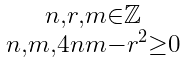Convert formula to latex. <formula><loc_0><loc_0><loc_500><loc_500>\begin{smallmatrix} n , r , m \in \mathbb { Z } \\ n , m , 4 n m - r ^ { 2 } \geq 0 \end{smallmatrix}</formula> 